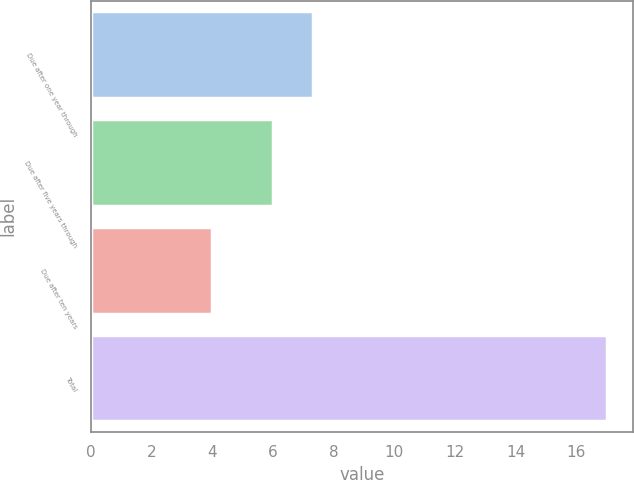Convert chart. <chart><loc_0><loc_0><loc_500><loc_500><bar_chart><fcel>Due after one year through<fcel>Due after five years through<fcel>Due after ten years<fcel>Total<nl><fcel>7.3<fcel>6<fcel>4<fcel>17<nl></chart> 